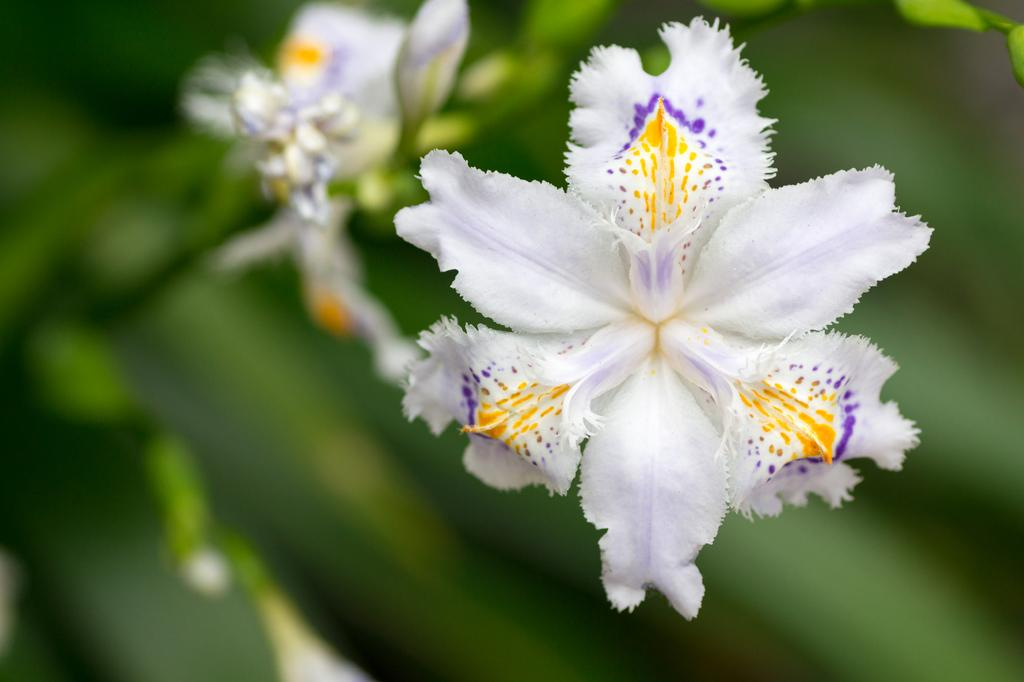What type of flora is present in the image? There are flowers in the image. What is the color of the flowers? The flowers are white in color. Are there any additional colors on the flowers? Yes, the flowers have yellow and blue color dots on them. What statement can be made about the learning process of the flowers in the image? There is no information about the learning process of the flowers in the image, as flowers do not have the ability to learn. 